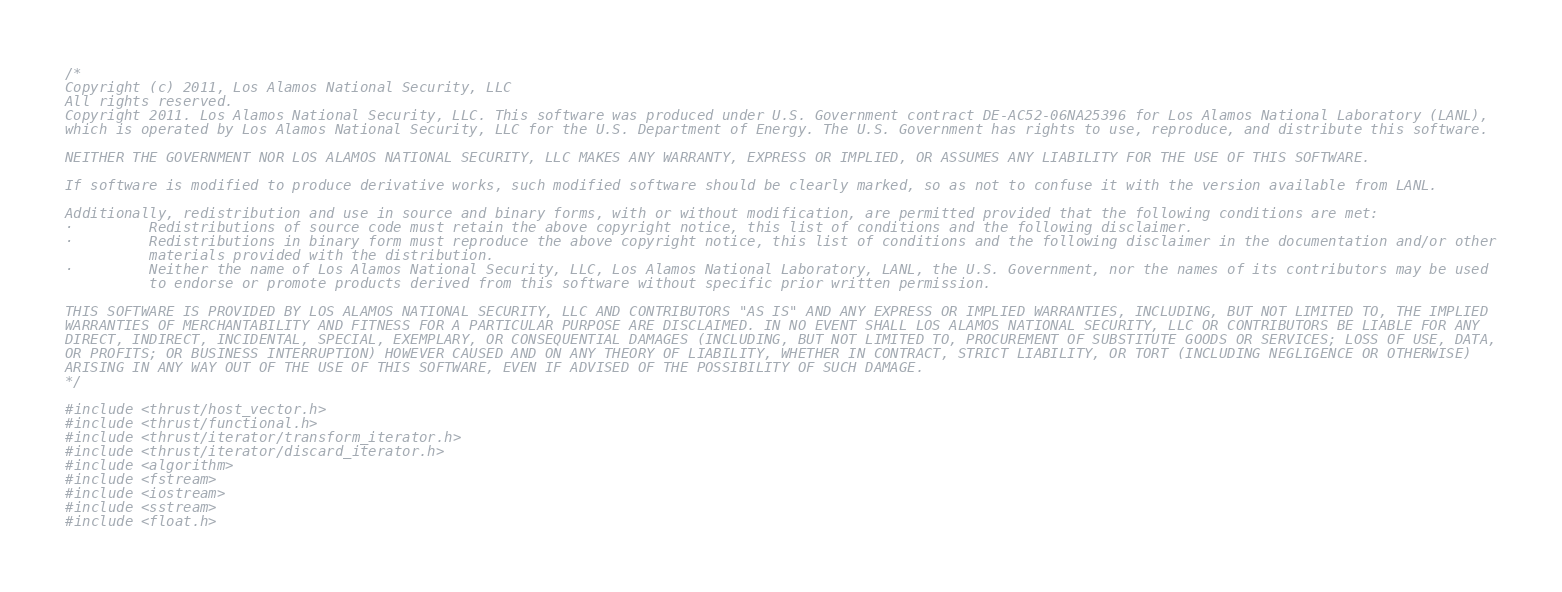Convert code to text. <code><loc_0><loc_0><loc_500><loc_500><_Cuda_>/*
Copyright (c) 2011, Los Alamos National Security, LLC
All rights reserved.
Copyright 2011. Los Alamos National Security, LLC. This software was produced under U.S. Government contract DE-AC52-06NA25396 for Los Alamos National Laboratory (LANL),
which is operated by Los Alamos National Security, LLC for the U.S. Department of Energy. The U.S. Government has rights to use, reproduce, and distribute this software.

NEITHER THE GOVERNMENT NOR LOS ALAMOS NATIONAL SECURITY, LLC MAKES ANY WARRANTY, EXPRESS OR IMPLIED, OR ASSUMES ANY LIABILITY FOR THE USE OF THIS SOFTWARE.

If software is modified to produce derivative works, such modified software should be clearly marked, so as not to confuse it with the version available from LANL.

Additionally, redistribution and use in source and binary forms, with or without modification, are permitted provided that the following conditions are met:
·         Redistributions of source code must retain the above copyright notice, this list of conditions and the following disclaimer.
·         Redistributions in binary form must reproduce the above copyright notice, this list of conditions and the following disclaimer in the documentation and/or other
          materials provided with the distribution.
·         Neither the name of Los Alamos National Security, LLC, Los Alamos National Laboratory, LANL, the U.S. Government, nor the names of its contributors may be used
          to endorse or promote products derived from this software without specific prior written permission.

THIS SOFTWARE IS PROVIDED BY LOS ALAMOS NATIONAL SECURITY, LLC AND CONTRIBUTORS "AS IS" AND ANY EXPRESS OR IMPLIED WARRANTIES, INCLUDING, BUT NOT LIMITED TO, THE IMPLIED
WARRANTIES OF MERCHANTABILITY AND FITNESS FOR A PARTICULAR PURPOSE ARE DISCLAIMED. IN NO EVENT SHALL LOS ALAMOS NATIONAL SECURITY, LLC OR CONTRIBUTORS BE LIABLE FOR ANY
DIRECT, INDIRECT, INCIDENTAL, SPECIAL, EXEMPLARY, OR CONSEQUENTIAL DAMAGES (INCLUDING, BUT NOT LIMITED TO, PROCUREMENT OF SUBSTITUTE GOODS OR SERVICES; LOSS OF USE, DATA,
OR PROFITS; OR BUSINESS INTERRUPTION) HOWEVER CAUSED AND ON ANY THEORY OF LIABILITY, WHETHER IN CONTRACT, STRICT LIABILITY, OR TORT (INCLUDING NEGLIGENCE OR OTHERWISE)
ARISING IN ANY WAY OUT OF THE USE OF THIS SOFTWARE, EVEN IF ADVISED OF THE POSSIBILITY OF SUCH DAMAGE.
*/

#include <thrust/host_vector.h>
#include <thrust/functional.h>
#include <thrust/iterator/transform_iterator.h>
#include <thrust/iterator/discard_iterator.h>
#include <algorithm>
#include <fstream>
#include <iostream>
#include <sstream>
#include <float.h>
</code> 